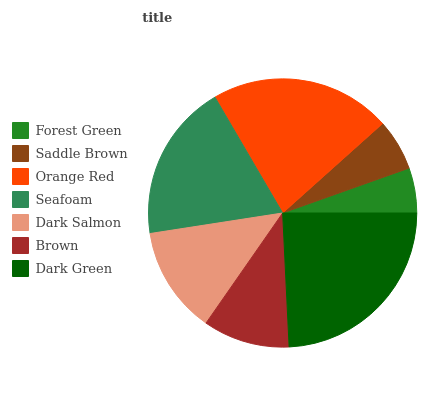Is Forest Green the minimum?
Answer yes or no. Yes. Is Dark Green the maximum?
Answer yes or no. Yes. Is Saddle Brown the minimum?
Answer yes or no. No. Is Saddle Brown the maximum?
Answer yes or no. No. Is Saddle Brown greater than Forest Green?
Answer yes or no. Yes. Is Forest Green less than Saddle Brown?
Answer yes or no. Yes. Is Forest Green greater than Saddle Brown?
Answer yes or no. No. Is Saddle Brown less than Forest Green?
Answer yes or no. No. Is Dark Salmon the high median?
Answer yes or no. Yes. Is Dark Salmon the low median?
Answer yes or no. Yes. Is Orange Red the high median?
Answer yes or no. No. Is Forest Green the low median?
Answer yes or no. No. 